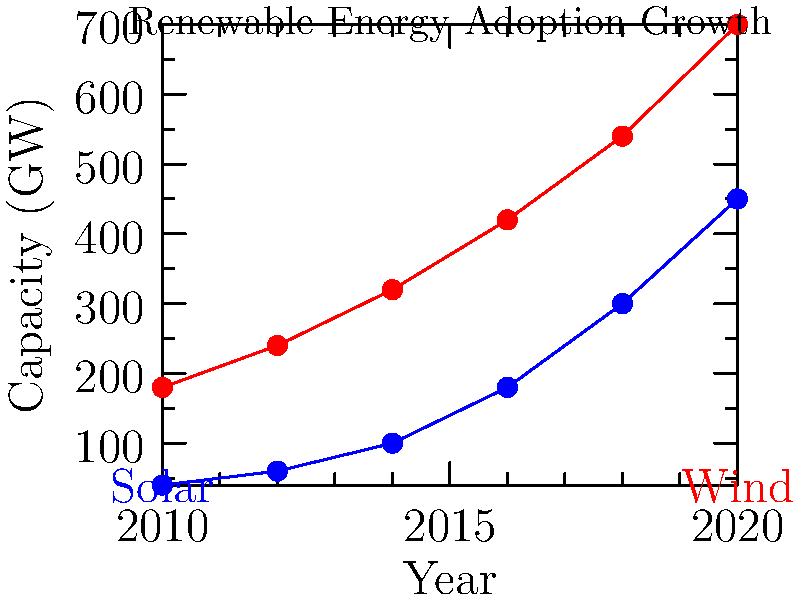Based on the line graph showing the growth of solar and wind energy adoption from 2010 to 2020, which renewable energy source had a higher average annual growth rate during this period? To determine which renewable energy source had a higher average annual growth rate, we need to calculate and compare the growth rates for solar and wind energy:

1. Calculate total growth for each energy source:
   Solar: 450 GW - 40 GW = 410 GW
   Wind: 700 GW - 180 GW = 520 GW

2. Calculate the average annual growth rate using the compound annual growth rate (CAGR) formula:
   $CAGR = (Ending Value / Beginning Value)^{(1/n)} - 1$
   where n is the number of years (10 in this case)

3. For Solar:
   $CAGR_{solar} = (450 / 40)^{(1/10)} - 1 = 0.2731 = 27.31\%$

4. For Wind:
   $CAGR_{wind} = (700 / 180)^{(1/10)} - 1 = 0.1454 = 14.54\%$

5. Compare the growth rates:
   Solar: 27.31% > Wind: 14.54%

Therefore, solar energy had a higher average annual growth rate during this period.
Answer: Solar energy 